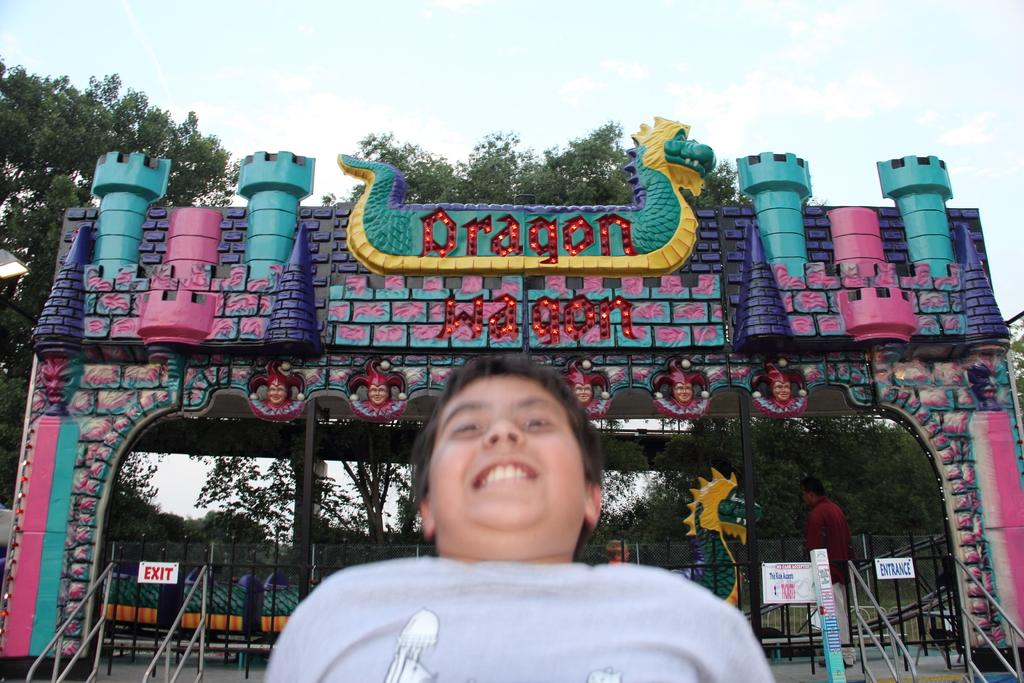Who is present in the image? There is a boy in the image. What can be seen in the background of the image? There is an entrance gate in the image, and trees are visible behind the entrance gate. Can you describe the entrance gate? The entrance gate is decorative. What might the entrance gate be associated with? The entrance gate is associated with an event. What type of honey is being collected from the trees in the image? There is no honey or tree-related activity present in the image. 